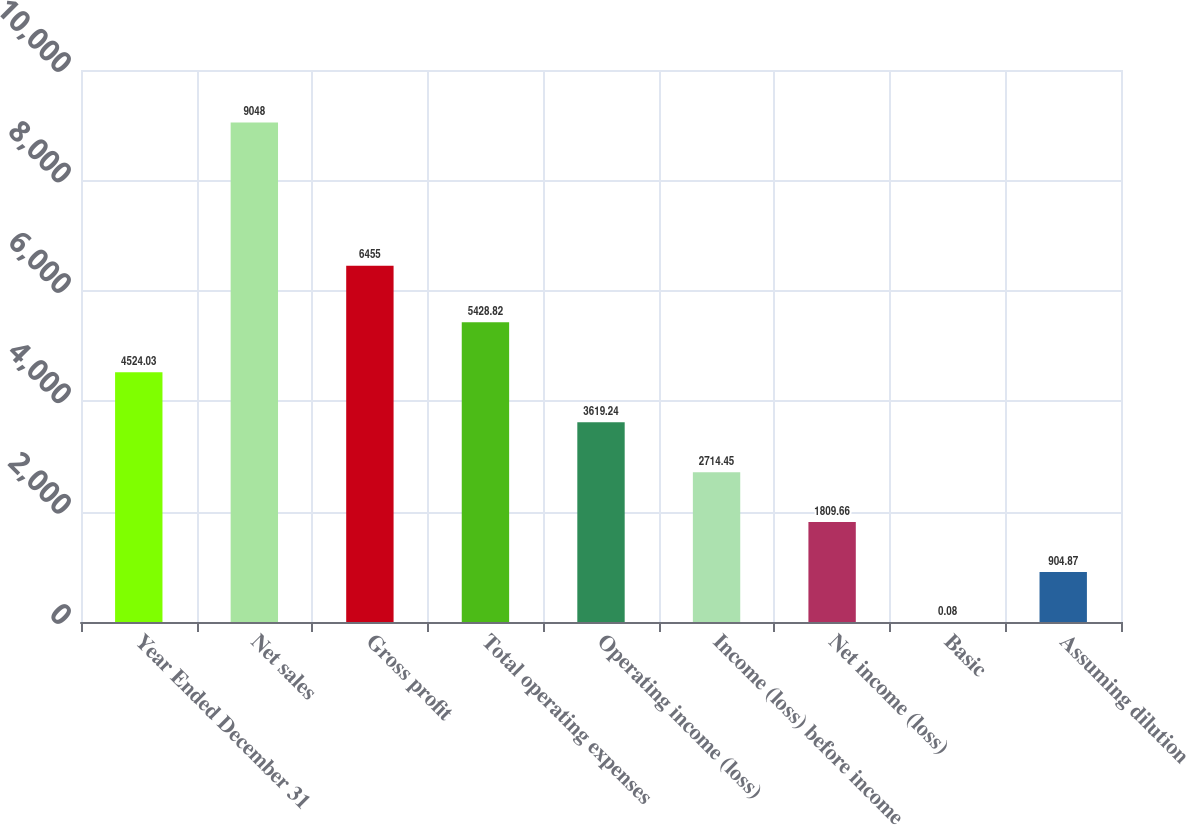<chart> <loc_0><loc_0><loc_500><loc_500><bar_chart><fcel>Year Ended December 31<fcel>Net sales<fcel>Gross profit<fcel>Total operating expenses<fcel>Operating income (loss)<fcel>Income (loss) before income<fcel>Net income (loss)<fcel>Basic<fcel>Assuming dilution<nl><fcel>4524.03<fcel>9048<fcel>6455<fcel>5428.82<fcel>3619.24<fcel>2714.45<fcel>1809.66<fcel>0.08<fcel>904.87<nl></chart> 